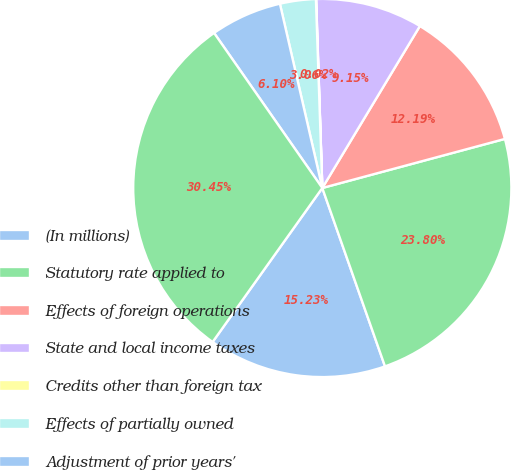Convert chart to OTSL. <chart><loc_0><loc_0><loc_500><loc_500><pie_chart><fcel>(In millions)<fcel>Statutory rate applied to<fcel>Effects of foreign operations<fcel>State and local income taxes<fcel>Credits other than foreign tax<fcel>Effects of partially owned<fcel>Adjustment of prior years'<fcel>Provision for income taxes<nl><fcel>15.23%<fcel>23.8%<fcel>12.19%<fcel>9.15%<fcel>0.02%<fcel>3.06%<fcel>6.1%<fcel>30.45%<nl></chart> 